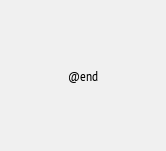<code> <loc_0><loc_0><loc_500><loc_500><_C_>
@end
</code> 